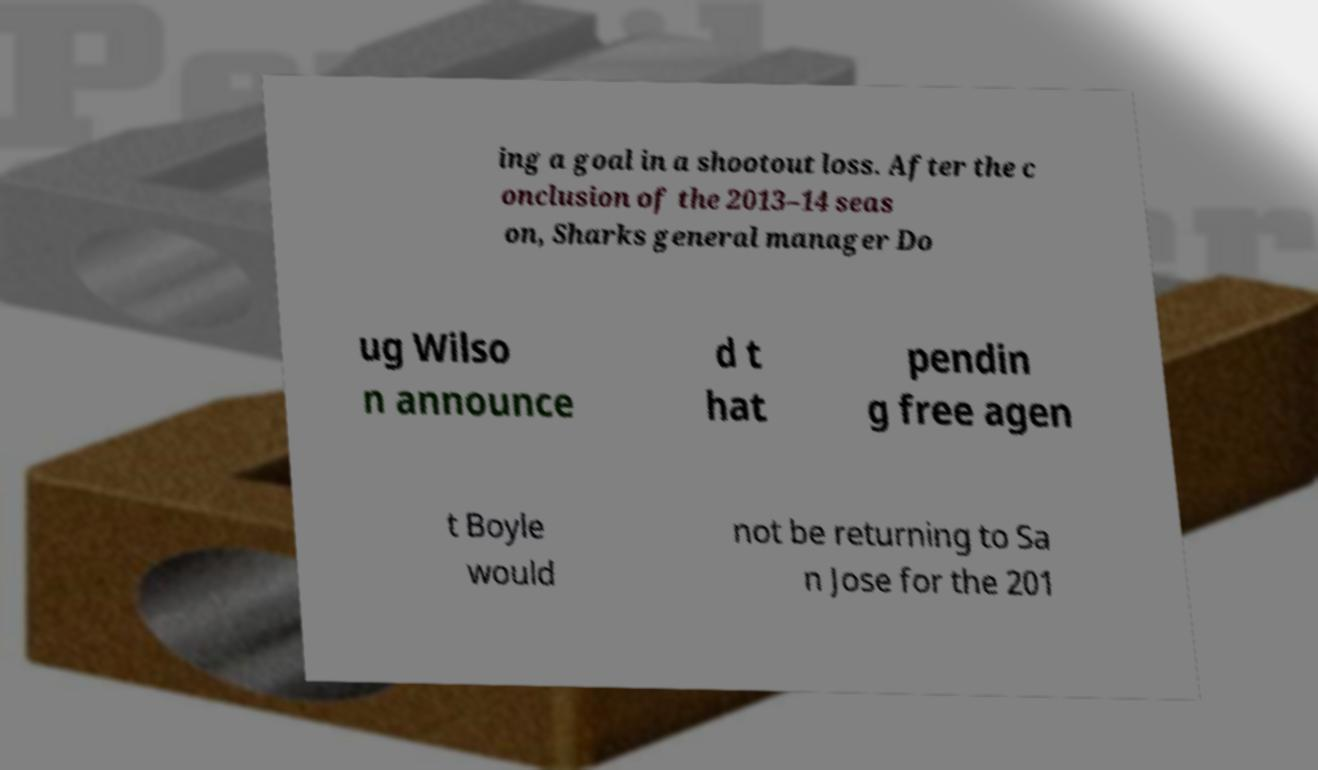Can you read and provide the text displayed in the image?This photo seems to have some interesting text. Can you extract and type it out for me? ing a goal in a shootout loss. After the c onclusion of the 2013–14 seas on, Sharks general manager Do ug Wilso n announce d t hat pendin g free agen t Boyle would not be returning to Sa n Jose for the 201 